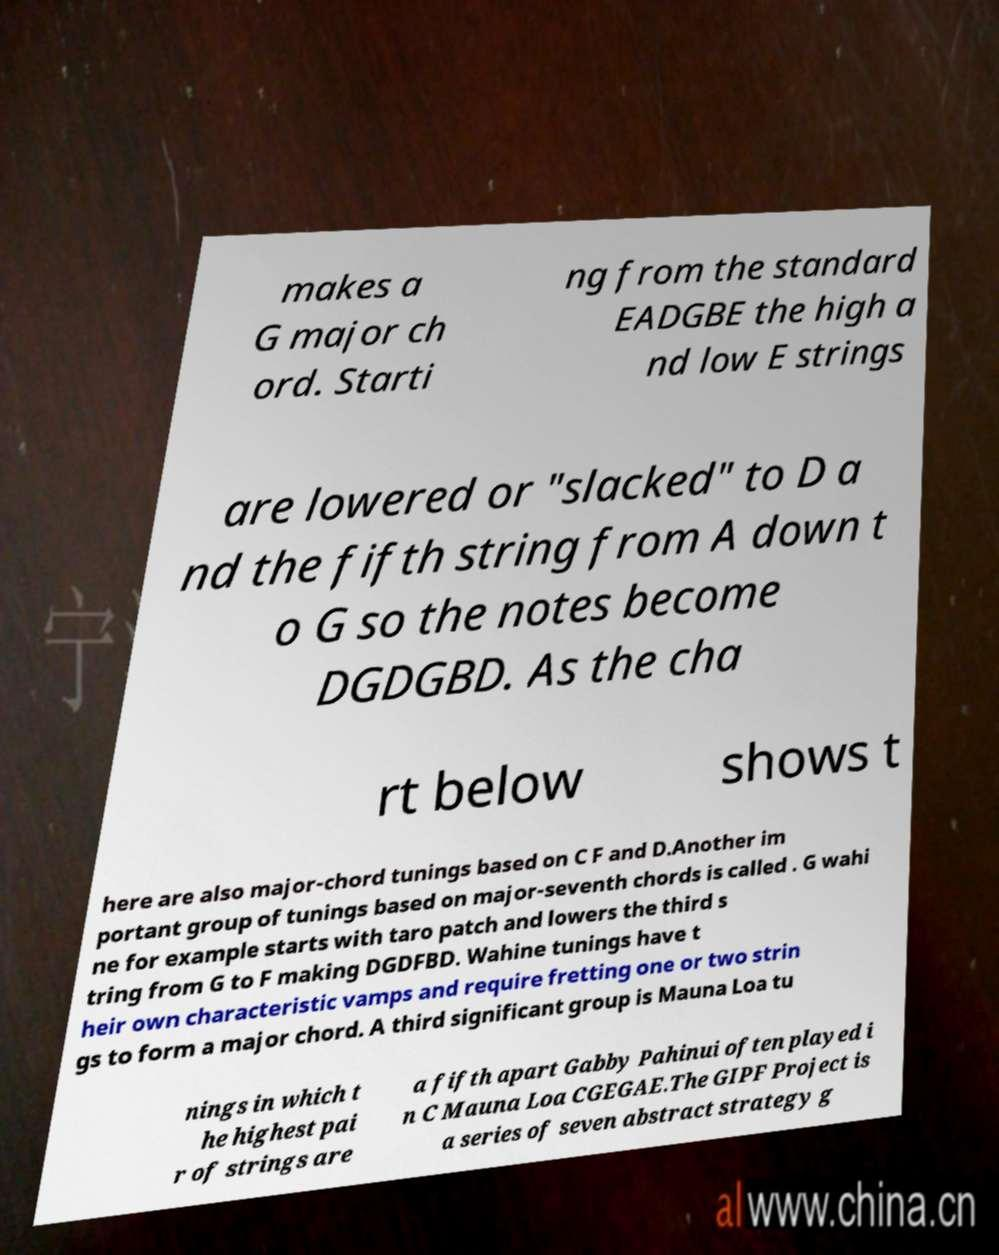Could you extract and type out the text from this image? makes a G major ch ord. Starti ng from the standard EADGBE the high a nd low E strings are lowered or "slacked" to D a nd the fifth string from A down t o G so the notes become DGDGBD. As the cha rt below shows t here are also major-chord tunings based on C F and D.Another im portant group of tunings based on major-seventh chords is called . G wahi ne for example starts with taro patch and lowers the third s tring from G to F making DGDFBD. Wahine tunings have t heir own characteristic vamps and require fretting one or two strin gs to form a major chord. A third significant group is Mauna Loa tu nings in which t he highest pai r of strings are a fifth apart Gabby Pahinui often played i n C Mauna Loa CGEGAE.The GIPF Project is a series of seven abstract strategy g 